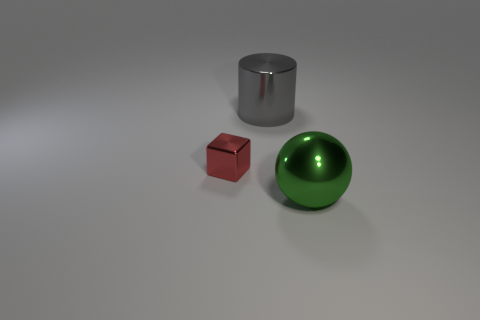How many green shiny cylinders have the same size as the green ball?
Offer a terse response. 0. Is the number of gray metallic cylinders behind the small metallic object less than the number of spheres behind the gray object?
Your answer should be very brief. No. What number of rubber things are either big green balls or small green objects?
Provide a succinct answer. 0. The large gray metallic thing is what shape?
Your response must be concise. Cylinder. There is a gray object that is the same size as the sphere; what material is it?
Keep it short and to the point. Metal. What number of large objects are balls or cylinders?
Ensure brevity in your answer.  2. Is there a gray metallic cylinder?
Give a very brief answer. Yes. What size is the gray cylinder that is made of the same material as the tiny object?
Offer a very short reply. Large. Do the red thing and the large gray cylinder have the same material?
Give a very brief answer. Yes. How many other things are there of the same material as the cylinder?
Your response must be concise. 2. 